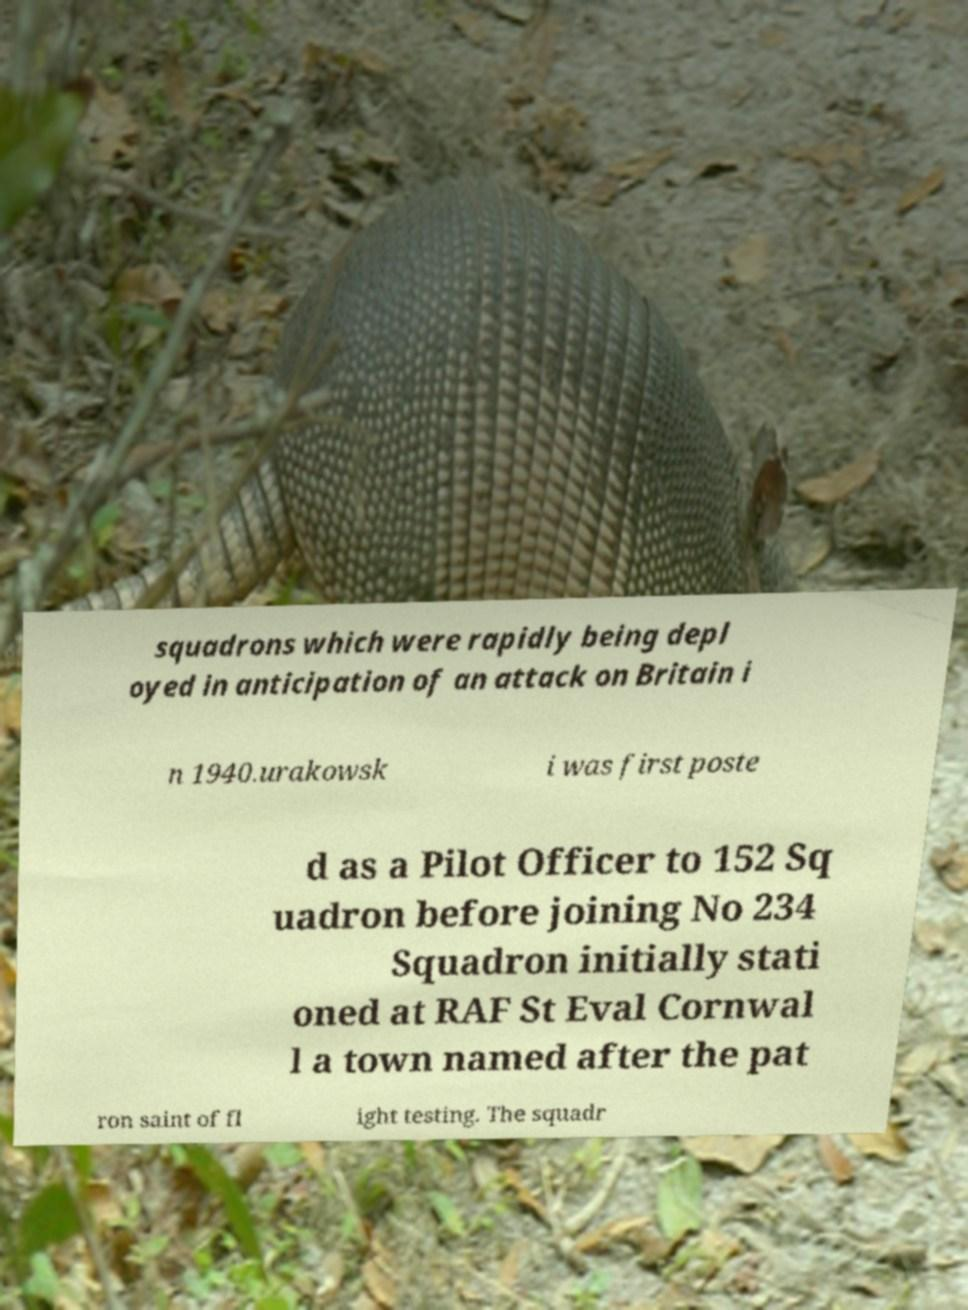I need the written content from this picture converted into text. Can you do that? squadrons which were rapidly being depl oyed in anticipation of an attack on Britain i n 1940.urakowsk i was first poste d as a Pilot Officer to 152 Sq uadron before joining No 234 Squadron initially stati oned at RAF St Eval Cornwal l a town named after the pat ron saint of fl ight testing. The squadr 